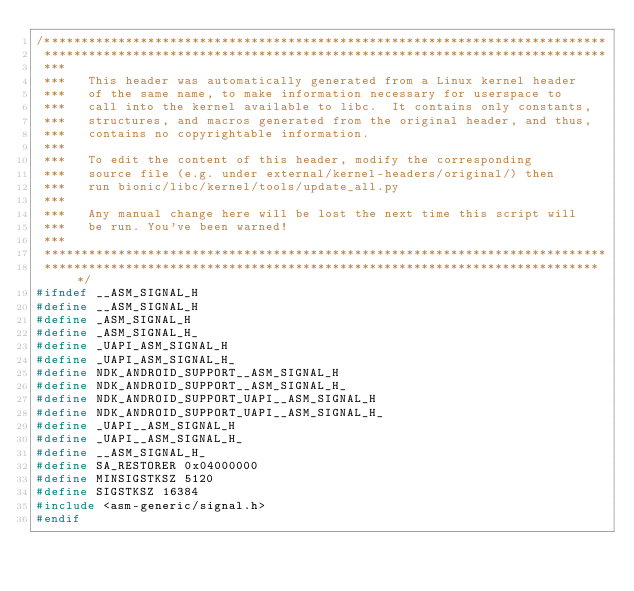Convert code to text. <code><loc_0><loc_0><loc_500><loc_500><_C_>/****************************************************************************
 ****************************************************************************
 ***
 ***   This header was automatically generated from a Linux kernel header
 ***   of the same name, to make information necessary for userspace to
 ***   call into the kernel available to libc.  It contains only constants,
 ***   structures, and macros generated from the original header, and thus,
 ***   contains no copyrightable information.
 ***
 ***   To edit the content of this header, modify the corresponding
 ***   source file (e.g. under external/kernel-headers/original/) then
 ***   run bionic/libc/kernel/tools/update_all.py
 ***
 ***   Any manual change here will be lost the next time this script will
 ***   be run. You've been warned!
 ***
 ****************************************************************************
 ****************************************************************************/
#ifndef __ASM_SIGNAL_H
#define __ASM_SIGNAL_H
#define _ASM_SIGNAL_H
#define _ASM_SIGNAL_H_
#define _UAPI_ASM_SIGNAL_H
#define _UAPI_ASM_SIGNAL_H_
#define NDK_ANDROID_SUPPORT__ASM_SIGNAL_H
#define NDK_ANDROID_SUPPORT__ASM_SIGNAL_H_
#define NDK_ANDROID_SUPPORT_UAPI__ASM_SIGNAL_H
#define NDK_ANDROID_SUPPORT_UAPI__ASM_SIGNAL_H_
#define _UAPI__ASM_SIGNAL_H
#define _UAPI__ASM_SIGNAL_H_
#define __ASM_SIGNAL_H_
#define SA_RESTORER 0x04000000
#define MINSIGSTKSZ 5120
#define SIGSTKSZ 16384
#include <asm-generic/signal.h>
#endif
</code> 